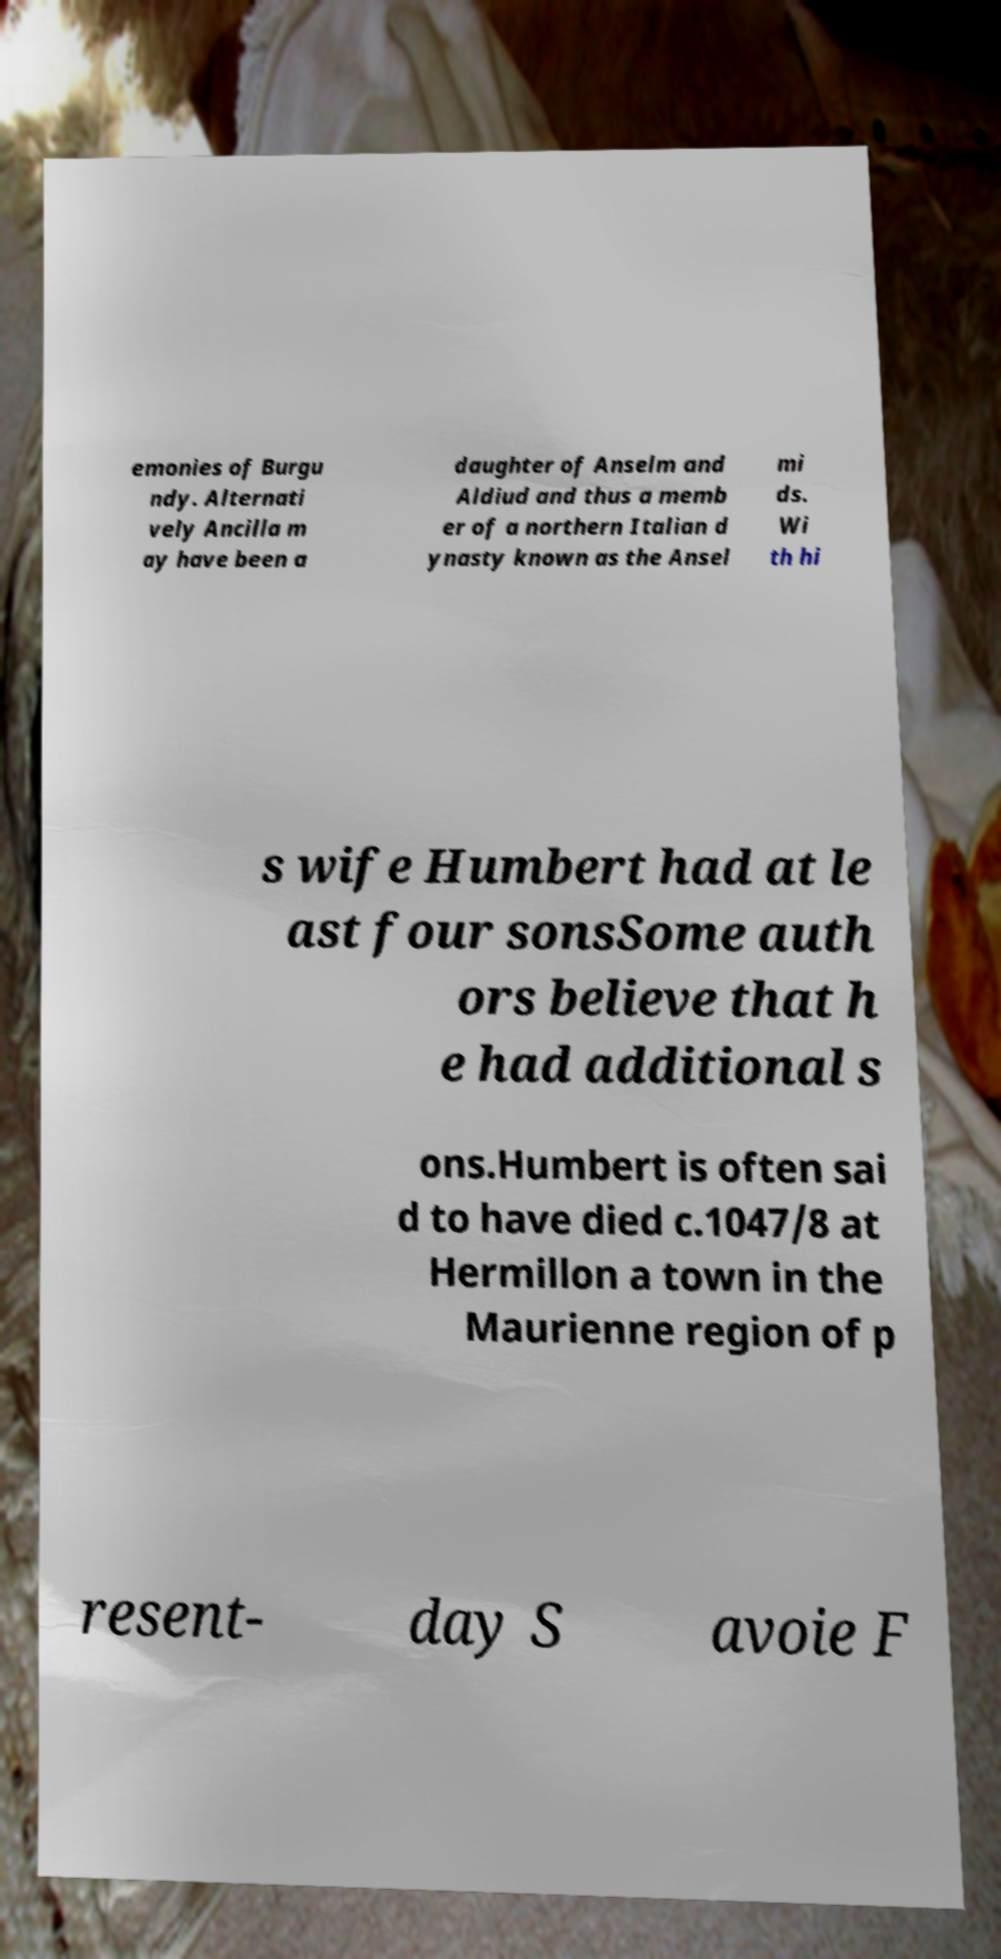For documentation purposes, I need the text within this image transcribed. Could you provide that? emonies of Burgu ndy. Alternati vely Ancilla m ay have been a daughter of Anselm and Aldiud and thus a memb er of a northern Italian d ynasty known as the Ansel mi ds. Wi th hi s wife Humbert had at le ast four sonsSome auth ors believe that h e had additional s ons.Humbert is often sai d to have died c.1047/8 at Hermillon a town in the Maurienne region of p resent- day S avoie F 